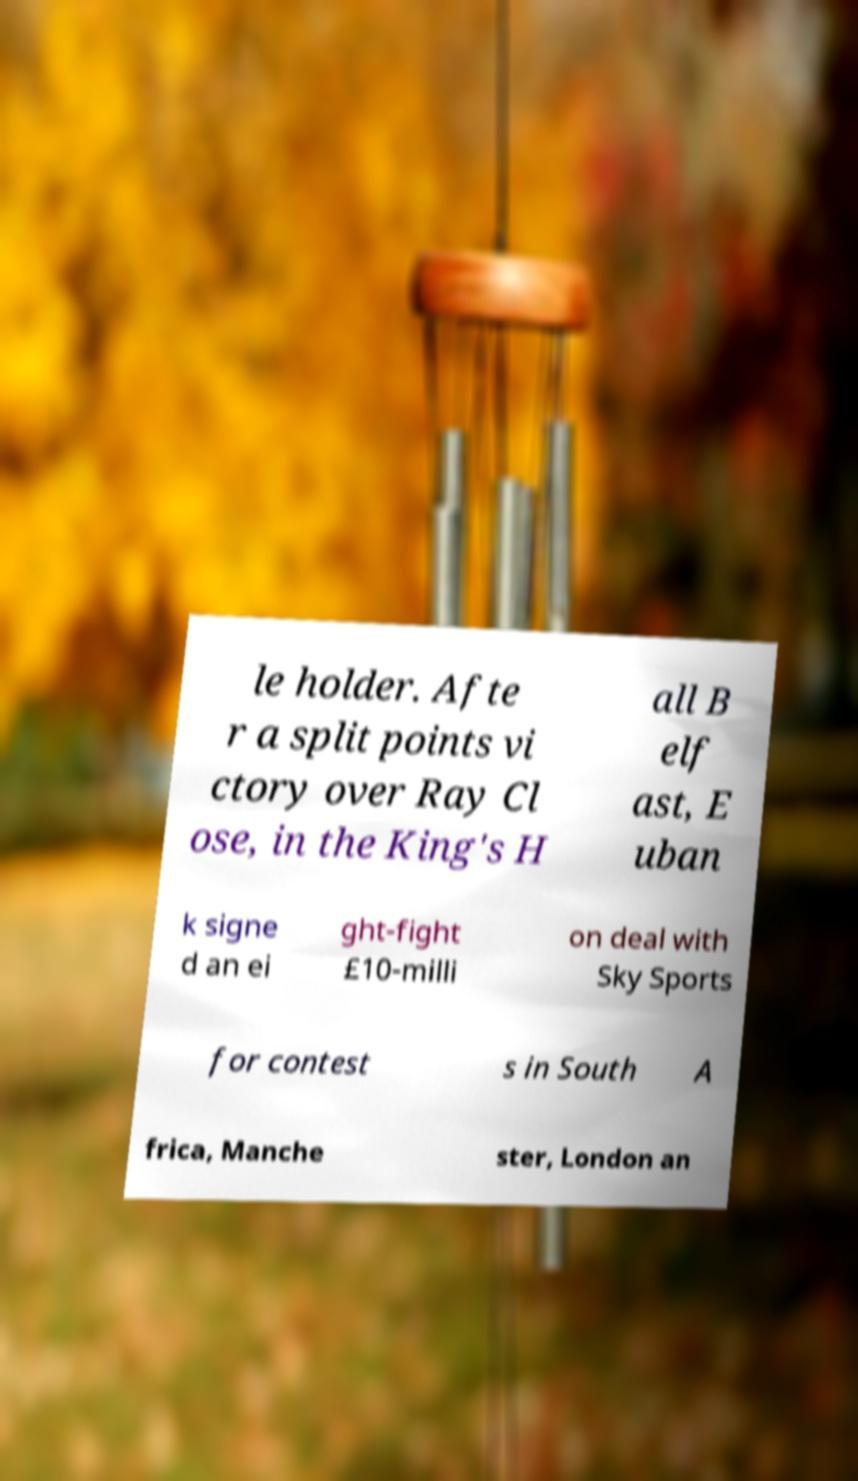For documentation purposes, I need the text within this image transcribed. Could you provide that? le holder. Afte r a split points vi ctory over Ray Cl ose, in the King's H all B elf ast, E uban k signe d an ei ght-fight £10-milli on deal with Sky Sports for contest s in South A frica, Manche ster, London an 